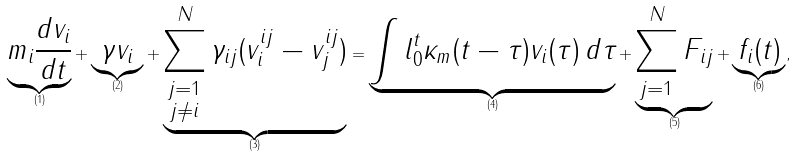Convert formula to latex. <formula><loc_0><loc_0><loc_500><loc_500>\underbrace { m _ { i } \frac { d v _ { i } } { d t } } _ { ( 1 ) } + \underbrace { \gamma v _ { i } } _ { ( 2 ) } + \underbrace { \sum _ { \substack { j = 1 \\ j \ne i } } ^ { N } \gamma _ { i j } ( v _ { i } ^ { i j } - v _ { j } ^ { i j } ) } _ { ( 3 ) } = \underbrace { \int l _ { 0 } ^ { t } \kappa _ { m } ( t - \tau ) v _ { i } ( \tau ) \, d \tau } _ { ( 4 ) } + \underbrace { \sum _ { j = 1 } ^ { N } F _ { i j } } _ { ( 5 ) } + \underbrace { f _ { i } ( t ) } _ { ( 6 ) } ,</formula> 